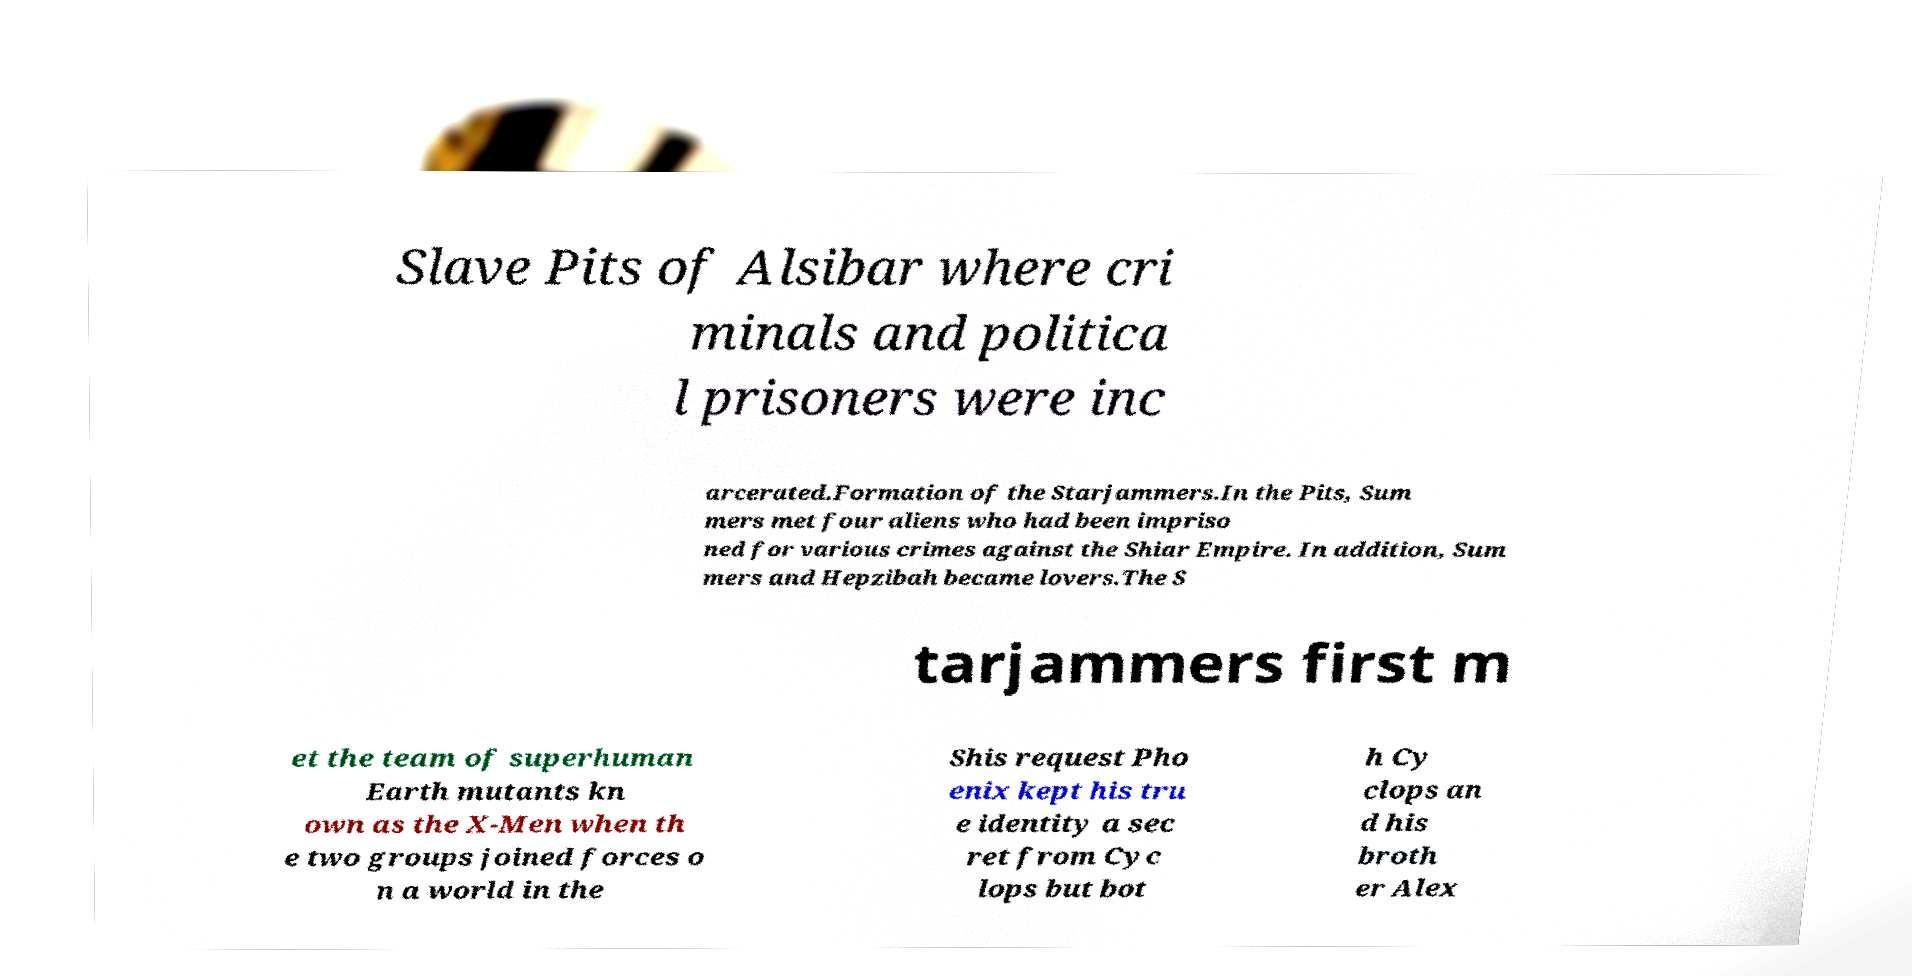What messages or text are displayed in this image? I need them in a readable, typed format. Slave Pits of Alsibar where cri minals and politica l prisoners were inc arcerated.Formation of the Starjammers.In the Pits, Sum mers met four aliens who had been impriso ned for various crimes against the Shiar Empire. In addition, Sum mers and Hepzibah became lovers.The S tarjammers first m et the team of superhuman Earth mutants kn own as the X-Men when th e two groups joined forces o n a world in the Shis request Pho enix kept his tru e identity a sec ret from Cyc lops but bot h Cy clops an d his broth er Alex 